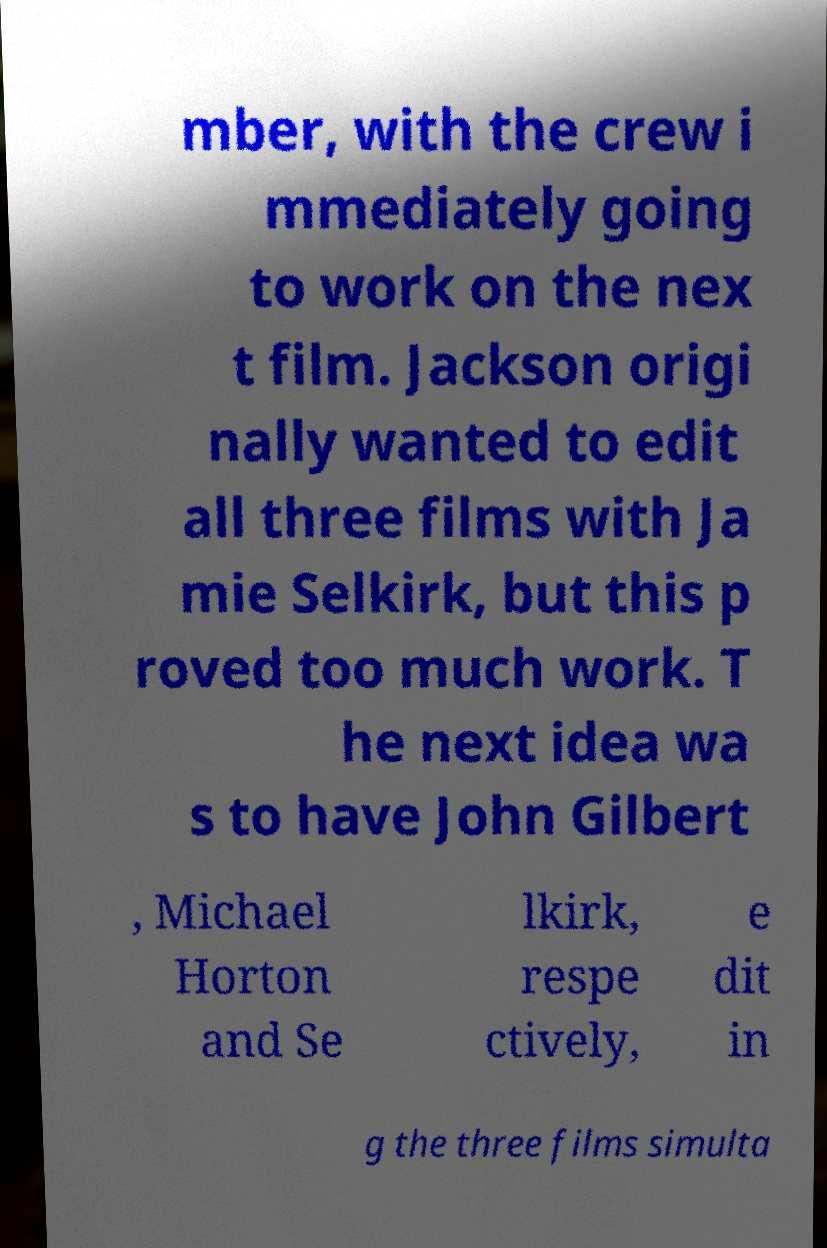Can you read and provide the text displayed in the image?This photo seems to have some interesting text. Can you extract and type it out for me? mber, with the crew i mmediately going to work on the nex t film. Jackson origi nally wanted to edit all three films with Ja mie Selkirk, but this p roved too much work. T he next idea wa s to have John Gilbert , Michael Horton and Se lkirk, respe ctively, e dit in g the three films simulta 